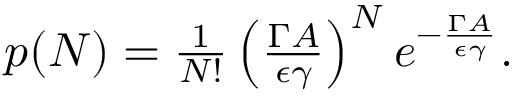<formula> <loc_0><loc_0><loc_500><loc_500>\begin{array} { r } { p ( N ) = \frac { 1 } { N ! } \left ( \frac { \Gamma A } { \epsilon \gamma } \right ) ^ { N } e ^ { - \frac { \Gamma A } { \epsilon \gamma } } . } \end{array}</formula> 